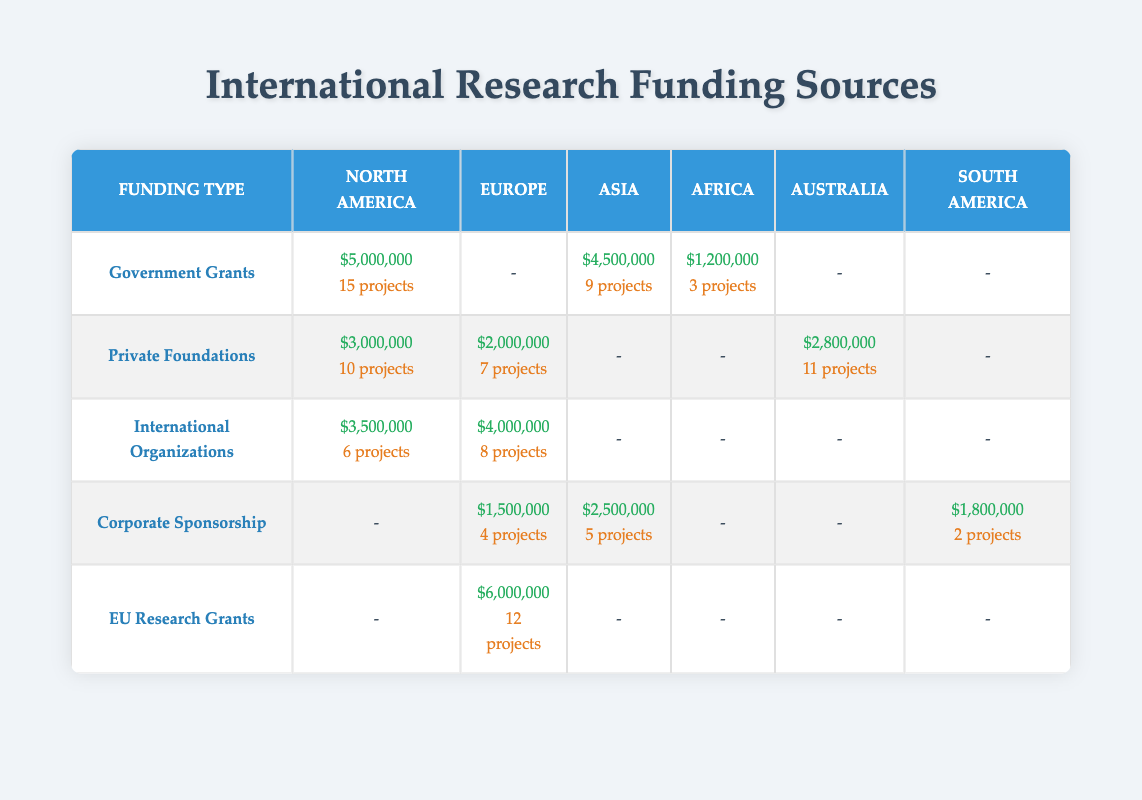What is the total amount funded by Government Grants in North America? The table shows that Government Grants in North America amount to $5,000,000. There are no other entries for this funding type in this region, so the total is simply the provided amount.
Answer: 5000000 How many projects are funded by Private Foundations in Australia? According to the table, Private Foundations in Australia have funded 11 projects, as listed under the appropriate region and funding type.
Answer: 11 What is the total amount of funding from International Organizations across all regions? The funding amounts from International Organizations are $3,500,000 for North America and $4,000,000 for Europe. Adding these together gives $3,500,000 + $4,000,000 = $7,500,000 for all regions.
Answer: 7500000 Is there any funding from EU Research Grants in North America? The table indicates that there is no entry for EU Research Grants in North America, denoted by a dash under that column.
Answer: No What is the difference in funding amount between Corporate Sponsorship in Asia and South America? The amounts for Corporate Sponsorship are $2,500,000 in Asia and $1,800,000 in South America. The difference is calculated as $2,500,000 - $1,800,000 = $700,000.
Answer: 700000 What region has the highest funding amount for EU Research Grants? The table shows that the only entry for EU Research Grants is in Europe, amounting to $6,000,000. Therefore, Europe has the highest funding for this category.
Answer: Europe Which Corporate Sponsorship region has the least amount of funding, and what is that amount? The table lists Corporate Sponsorship amounts as $2,500,000 in Asia, $1,800,000 in South America, and $1,500,000 in Europe. The lowest among these is $1,500,000 from Europe.
Answer: $1500000 How many projects have been funded by International Organizations in North America and Europe combined? The table indicates 6 projects funded by International Organizations in North America and 8 projects in Europe. Adding these together gives 6 + 8 = 14 projects.
Answer: 14 What percentage of the total funding from Private Foundations comes from Australia? The total funding for Private Foundations is $3,000,000 (North America) + $2,000,000 (Europe) + $2,800,000 (Australia) = $7,800,000. The contribution from Australia is $2,800,000. The percentage is calculated as ($2,800,000 / $7,800,000) * 100 = 35.9%.
Answer: 35.9% 